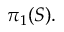<formula> <loc_0><loc_0><loc_500><loc_500>\pi _ { 1 } ( S ) .</formula> 